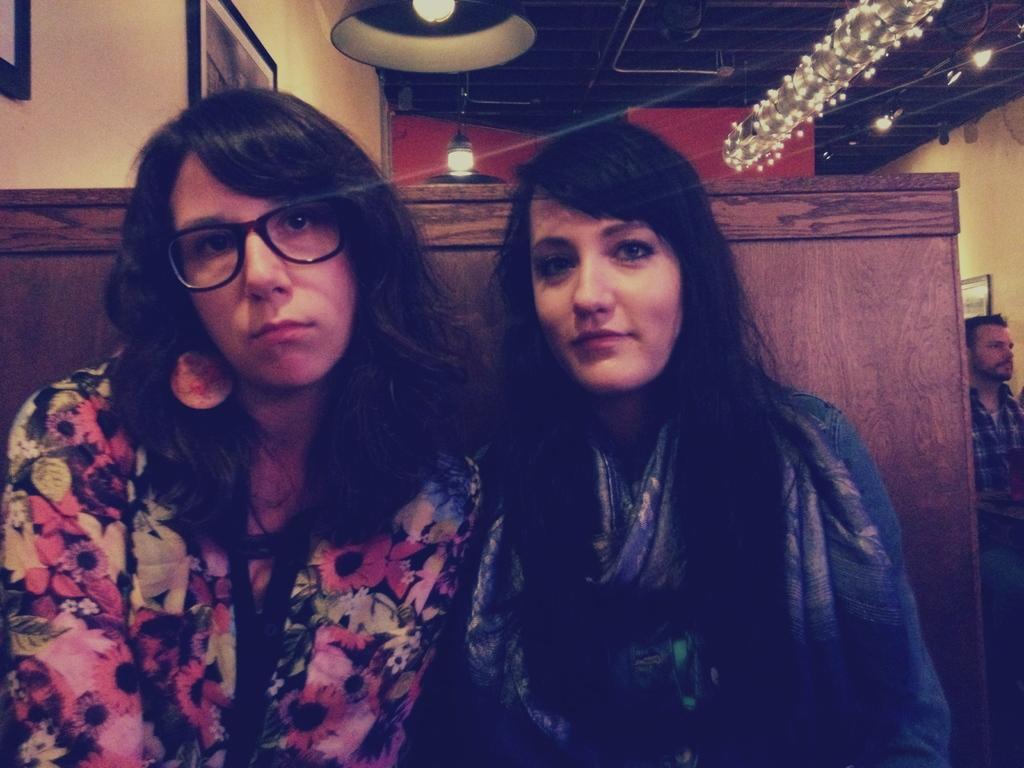Could you give a brief overview of what you see in this image? In this picture I can observe two women. One of them is smiling. One of them is wearing spectacles. On the right side I can observe a man. In the background I can observe some lights hanged to the ceiling. On the left side I can observe photo frames on the wall. 